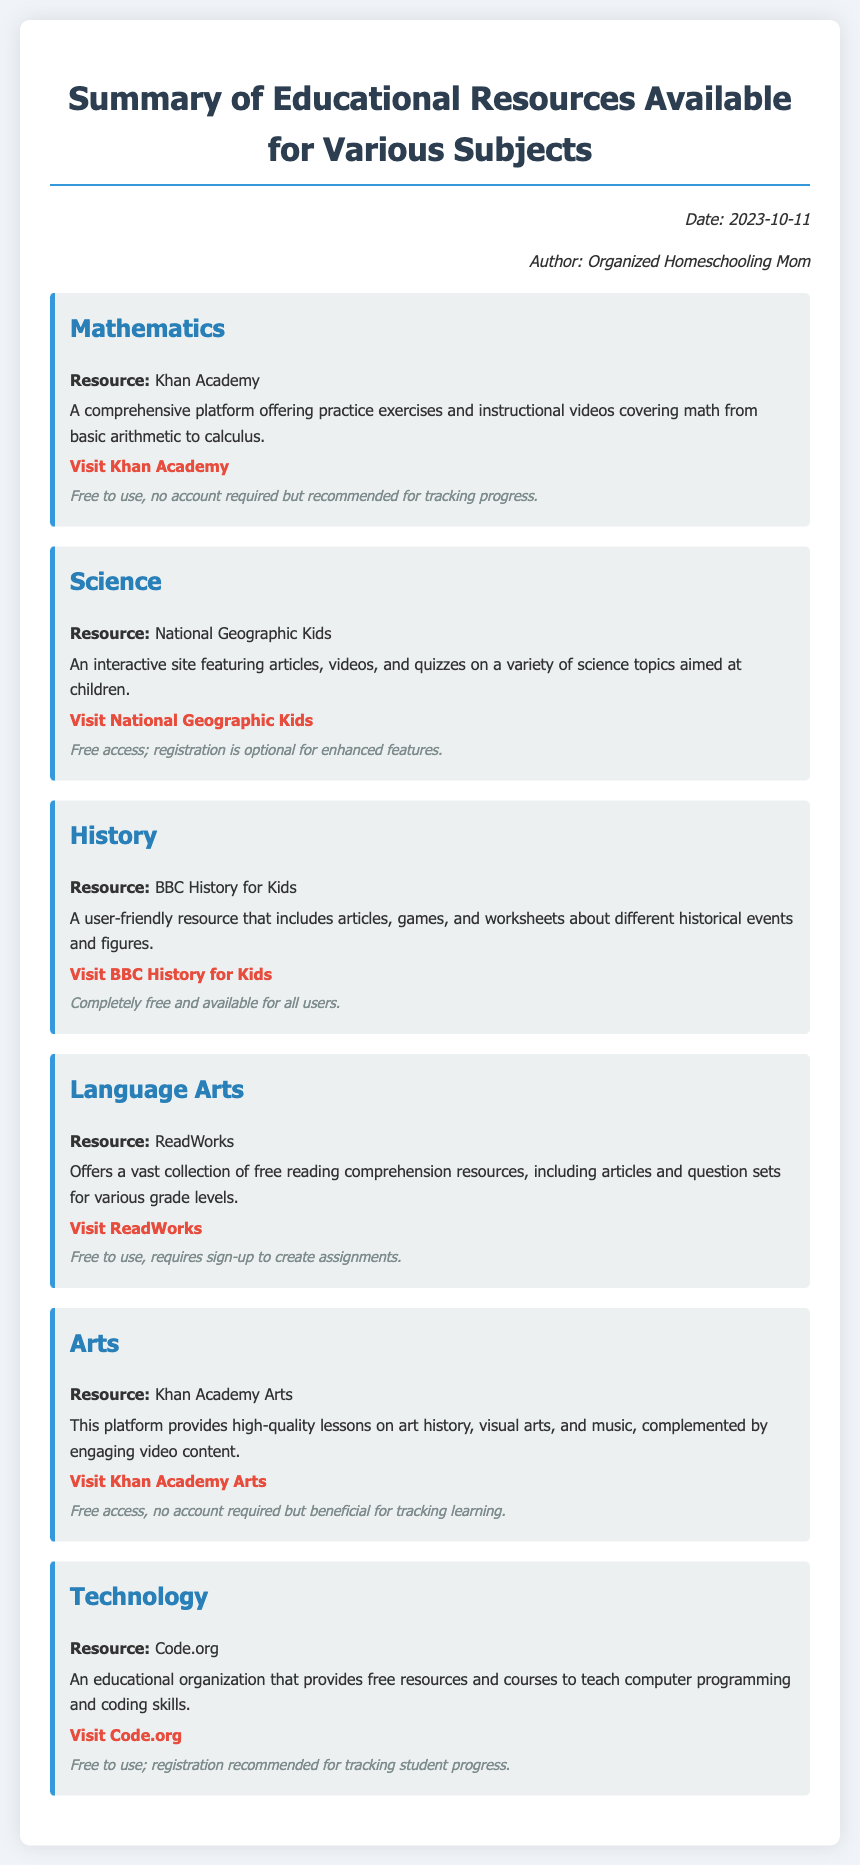What is the date of the memo? The date of the memo is explicitly mentioned at the top of the document.
Answer: 2023-10-11 Who is the author of the memo? The author of the memo is noted in the memo information section.
Answer: Organized Homeschooling Mom What resource is provided for Mathematics? The document includes specific resources for each subject along with their links, including Mathematics.
Answer: Khan Academy What is the access detail for Code.org? The access details specify if registration is required for each resource, including Code.org.
Answer: Free to use; registration recommended for tracking student progress Which subject's resource offers reading comprehension resources? The document lists specific subjects along with their respective resources including reading comprehension.
Answer: Language Arts What type of content does BBC History for Kids provide? The memo describes the type of content each resource offers, specifically for history.
Answer: Articles, games, and worksheets How many subjects are covered in the memo? The number of subjects is indicated by the number of resource sections in the document.
Answer: Six What main feature does National Geographic Kids emphasize? The memo highlights specific features of each resource, including interactivity for National Geographic Kids.
Answer: Interactive site Is an account required to use ReadWorks? The access details indicate whether an account is necessary for each resource, including ReadWorks.
Answer: Requires sign-up to create assignments 